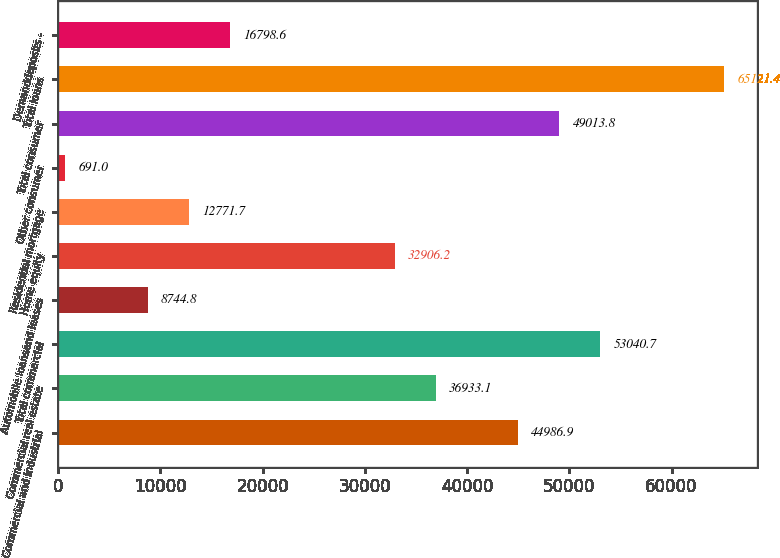Convert chart to OTSL. <chart><loc_0><loc_0><loc_500><loc_500><bar_chart><fcel>Commercial and industrial<fcel>Commercial real estate<fcel>Total commercial<fcel>Automobile loansand leases<fcel>Home equity<fcel>Residential mortgage<fcel>Other consumer<fcel>Total consumer<fcel>Total loans<fcel>Demanddeposits -<nl><fcel>44986.9<fcel>36933.1<fcel>53040.7<fcel>8744.8<fcel>32906.2<fcel>12771.7<fcel>691<fcel>49013.8<fcel>65121.4<fcel>16798.6<nl></chart> 